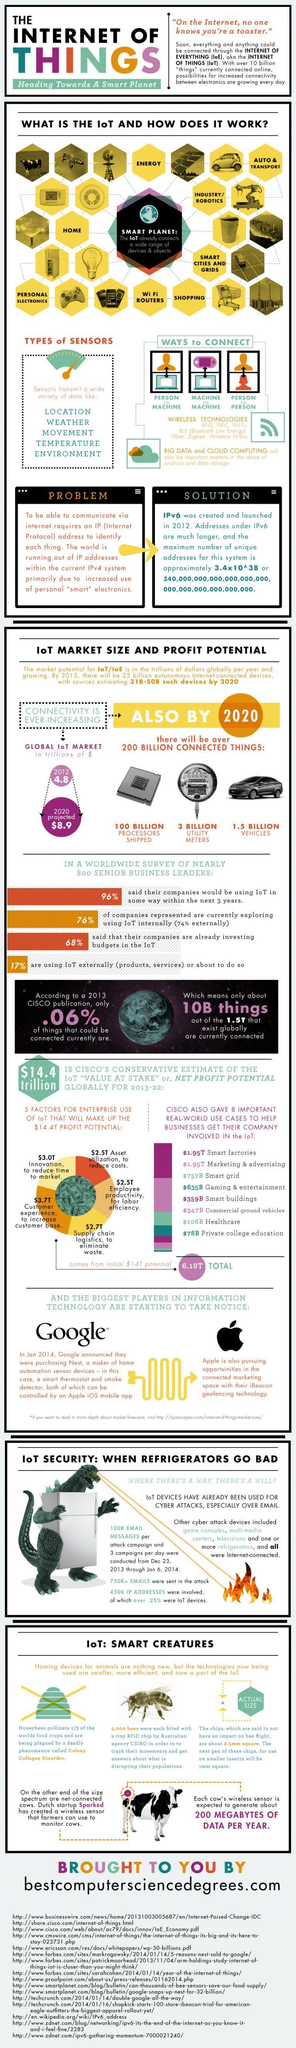How many wide varieties of data sensors transmit?
Answer the question with a short phrase. 5 How many ways to connect? 3 Which is the third variety of data sensors transmit in this infographic? movement What is the number of utility meters? 3 billion How many wireless technologies mentioned in this infographic? 7 Which is the second variety of data sensors transmit in this infographic? weather What is the number of processed chips? 100 billion 